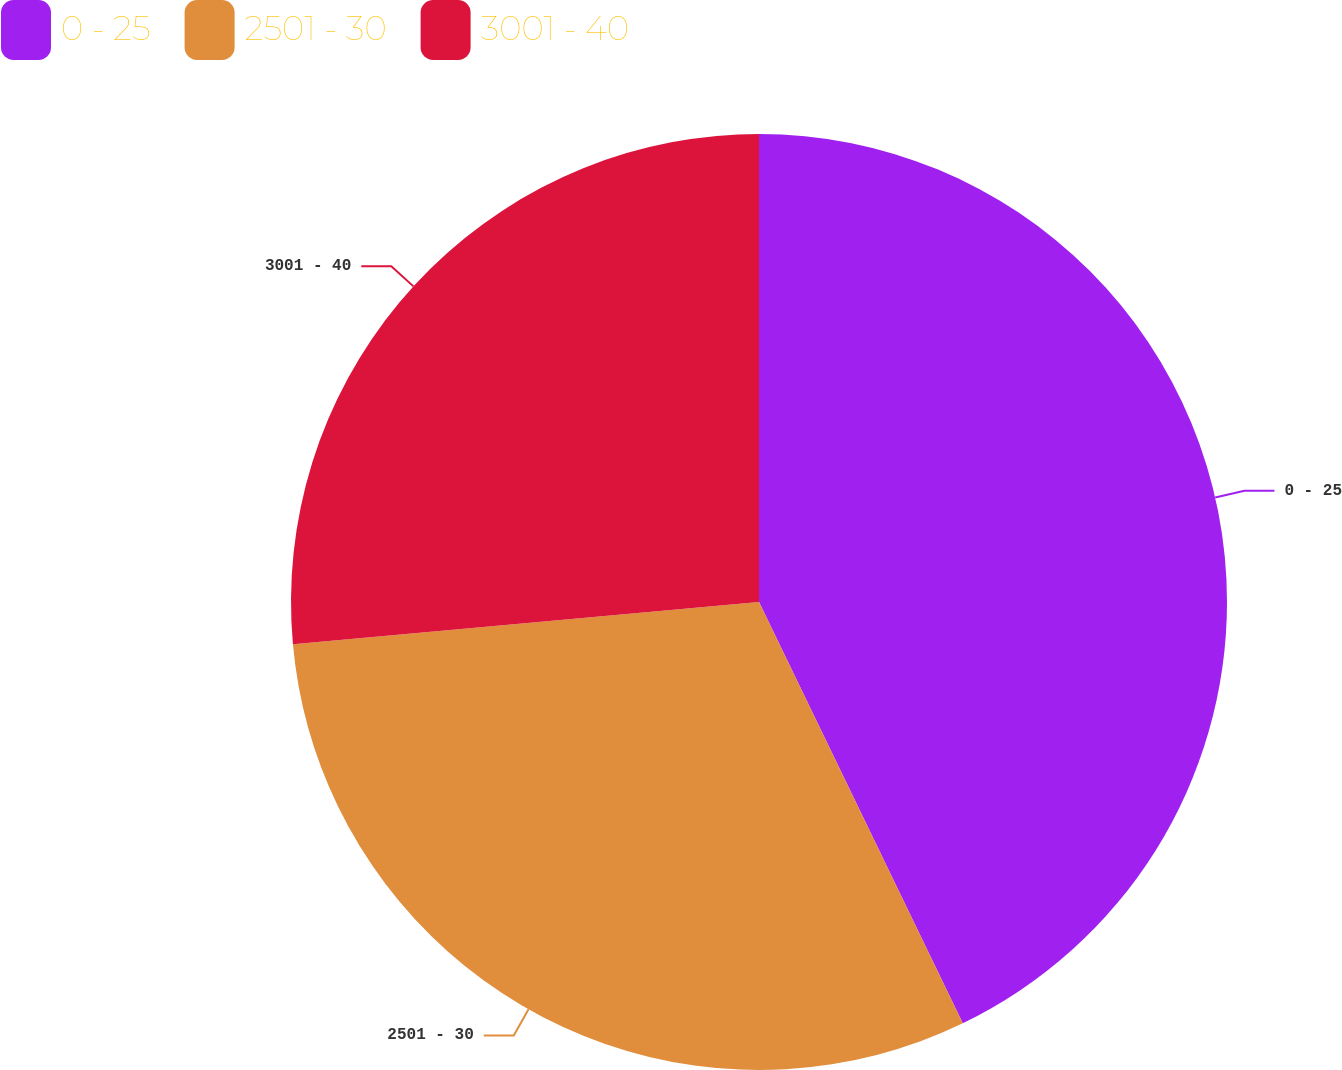Convert chart to OTSL. <chart><loc_0><loc_0><loc_500><loc_500><pie_chart><fcel>0 - 25<fcel>2501 - 30<fcel>3001 - 40<nl><fcel>42.83%<fcel>30.73%<fcel>26.44%<nl></chart> 